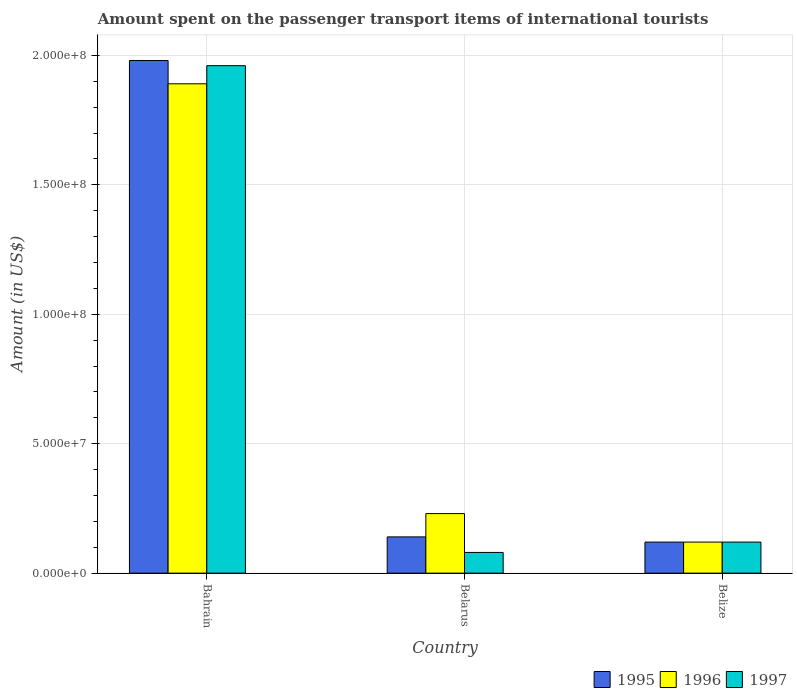How many different coloured bars are there?
Offer a very short reply. 3. How many bars are there on the 1st tick from the left?
Keep it short and to the point. 3. How many bars are there on the 1st tick from the right?
Provide a short and direct response. 3. What is the label of the 1st group of bars from the left?
Provide a short and direct response. Bahrain. In how many cases, is the number of bars for a given country not equal to the number of legend labels?
Your response must be concise. 0. What is the amount spent on the passenger transport items of international tourists in 1997 in Bahrain?
Your response must be concise. 1.96e+08. Across all countries, what is the maximum amount spent on the passenger transport items of international tourists in 1996?
Ensure brevity in your answer.  1.89e+08. Across all countries, what is the minimum amount spent on the passenger transport items of international tourists in 1996?
Your answer should be very brief. 1.20e+07. In which country was the amount spent on the passenger transport items of international tourists in 1997 maximum?
Provide a short and direct response. Bahrain. In which country was the amount spent on the passenger transport items of international tourists in 1996 minimum?
Ensure brevity in your answer.  Belize. What is the total amount spent on the passenger transport items of international tourists in 1996 in the graph?
Your answer should be very brief. 2.24e+08. What is the difference between the amount spent on the passenger transport items of international tourists in 1995 in Belarus and that in Belize?
Give a very brief answer. 2.00e+06. What is the difference between the amount spent on the passenger transport items of international tourists in 1997 in Bahrain and the amount spent on the passenger transport items of international tourists in 1996 in Belarus?
Your answer should be compact. 1.73e+08. What is the average amount spent on the passenger transport items of international tourists in 1995 per country?
Keep it short and to the point. 7.47e+07. What is the difference between the amount spent on the passenger transport items of international tourists of/in 1997 and amount spent on the passenger transport items of international tourists of/in 1995 in Belarus?
Make the answer very short. -6.00e+06. What is the ratio of the amount spent on the passenger transport items of international tourists in 1995 in Bahrain to that in Belize?
Ensure brevity in your answer.  16.5. Is the amount spent on the passenger transport items of international tourists in 1997 in Belarus less than that in Belize?
Keep it short and to the point. Yes. What is the difference between the highest and the second highest amount spent on the passenger transport items of international tourists in 1997?
Your answer should be compact. 1.84e+08. What is the difference between the highest and the lowest amount spent on the passenger transport items of international tourists in 1996?
Give a very brief answer. 1.77e+08. Is the sum of the amount spent on the passenger transport items of international tourists in 1996 in Belarus and Belize greater than the maximum amount spent on the passenger transport items of international tourists in 1995 across all countries?
Offer a terse response. No. What does the 2nd bar from the left in Bahrain represents?
Keep it short and to the point. 1996. Is it the case that in every country, the sum of the amount spent on the passenger transport items of international tourists in 1996 and amount spent on the passenger transport items of international tourists in 1995 is greater than the amount spent on the passenger transport items of international tourists in 1997?
Provide a short and direct response. Yes. Are all the bars in the graph horizontal?
Give a very brief answer. No. What is the difference between two consecutive major ticks on the Y-axis?
Provide a succinct answer. 5.00e+07. Are the values on the major ticks of Y-axis written in scientific E-notation?
Provide a short and direct response. Yes. Does the graph contain any zero values?
Offer a terse response. No. Does the graph contain grids?
Your response must be concise. Yes. How many legend labels are there?
Ensure brevity in your answer.  3. How are the legend labels stacked?
Give a very brief answer. Horizontal. What is the title of the graph?
Keep it short and to the point. Amount spent on the passenger transport items of international tourists. What is the label or title of the Y-axis?
Give a very brief answer. Amount (in US$). What is the Amount (in US$) in 1995 in Bahrain?
Make the answer very short. 1.98e+08. What is the Amount (in US$) of 1996 in Bahrain?
Provide a succinct answer. 1.89e+08. What is the Amount (in US$) of 1997 in Bahrain?
Provide a succinct answer. 1.96e+08. What is the Amount (in US$) in 1995 in Belarus?
Your response must be concise. 1.40e+07. What is the Amount (in US$) of 1996 in Belarus?
Offer a terse response. 2.30e+07. What is the Amount (in US$) in 1995 in Belize?
Your answer should be very brief. 1.20e+07. What is the Amount (in US$) in 1996 in Belize?
Ensure brevity in your answer.  1.20e+07. Across all countries, what is the maximum Amount (in US$) of 1995?
Make the answer very short. 1.98e+08. Across all countries, what is the maximum Amount (in US$) of 1996?
Your response must be concise. 1.89e+08. Across all countries, what is the maximum Amount (in US$) in 1997?
Give a very brief answer. 1.96e+08. Across all countries, what is the minimum Amount (in US$) of 1995?
Offer a terse response. 1.20e+07. Across all countries, what is the minimum Amount (in US$) of 1997?
Make the answer very short. 8.00e+06. What is the total Amount (in US$) of 1995 in the graph?
Your answer should be compact. 2.24e+08. What is the total Amount (in US$) in 1996 in the graph?
Provide a short and direct response. 2.24e+08. What is the total Amount (in US$) in 1997 in the graph?
Provide a succinct answer. 2.16e+08. What is the difference between the Amount (in US$) in 1995 in Bahrain and that in Belarus?
Offer a terse response. 1.84e+08. What is the difference between the Amount (in US$) in 1996 in Bahrain and that in Belarus?
Provide a short and direct response. 1.66e+08. What is the difference between the Amount (in US$) of 1997 in Bahrain and that in Belarus?
Keep it short and to the point. 1.88e+08. What is the difference between the Amount (in US$) of 1995 in Bahrain and that in Belize?
Your answer should be very brief. 1.86e+08. What is the difference between the Amount (in US$) in 1996 in Bahrain and that in Belize?
Make the answer very short. 1.77e+08. What is the difference between the Amount (in US$) in 1997 in Bahrain and that in Belize?
Your response must be concise. 1.84e+08. What is the difference between the Amount (in US$) in 1996 in Belarus and that in Belize?
Offer a very short reply. 1.10e+07. What is the difference between the Amount (in US$) in 1995 in Bahrain and the Amount (in US$) in 1996 in Belarus?
Provide a succinct answer. 1.75e+08. What is the difference between the Amount (in US$) in 1995 in Bahrain and the Amount (in US$) in 1997 in Belarus?
Keep it short and to the point. 1.90e+08. What is the difference between the Amount (in US$) in 1996 in Bahrain and the Amount (in US$) in 1997 in Belarus?
Your answer should be very brief. 1.81e+08. What is the difference between the Amount (in US$) in 1995 in Bahrain and the Amount (in US$) in 1996 in Belize?
Make the answer very short. 1.86e+08. What is the difference between the Amount (in US$) of 1995 in Bahrain and the Amount (in US$) of 1997 in Belize?
Offer a very short reply. 1.86e+08. What is the difference between the Amount (in US$) in 1996 in Bahrain and the Amount (in US$) in 1997 in Belize?
Your response must be concise. 1.77e+08. What is the difference between the Amount (in US$) of 1995 in Belarus and the Amount (in US$) of 1996 in Belize?
Provide a succinct answer. 2.00e+06. What is the difference between the Amount (in US$) of 1995 in Belarus and the Amount (in US$) of 1997 in Belize?
Make the answer very short. 2.00e+06. What is the difference between the Amount (in US$) of 1996 in Belarus and the Amount (in US$) of 1997 in Belize?
Provide a short and direct response. 1.10e+07. What is the average Amount (in US$) of 1995 per country?
Give a very brief answer. 7.47e+07. What is the average Amount (in US$) in 1996 per country?
Ensure brevity in your answer.  7.47e+07. What is the average Amount (in US$) in 1997 per country?
Give a very brief answer. 7.20e+07. What is the difference between the Amount (in US$) in 1995 and Amount (in US$) in 1996 in Bahrain?
Your answer should be very brief. 9.00e+06. What is the difference between the Amount (in US$) of 1995 and Amount (in US$) of 1997 in Bahrain?
Keep it short and to the point. 2.00e+06. What is the difference between the Amount (in US$) in 1996 and Amount (in US$) in 1997 in Bahrain?
Your answer should be compact. -7.00e+06. What is the difference between the Amount (in US$) of 1995 and Amount (in US$) of 1996 in Belarus?
Keep it short and to the point. -9.00e+06. What is the difference between the Amount (in US$) in 1995 and Amount (in US$) in 1997 in Belarus?
Provide a short and direct response. 6.00e+06. What is the difference between the Amount (in US$) of 1996 and Amount (in US$) of 1997 in Belarus?
Make the answer very short. 1.50e+07. What is the difference between the Amount (in US$) of 1995 and Amount (in US$) of 1996 in Belize?
Ensure brevity in your answer.  0. What is the difference between the Amount (in US$) of 1995 and Amount (in US$) of 1997 in Belize?
Ensure brevity in your answer.  0. What is the ratio of the Amount (in US$) in 1995 in Bahrain to that in Belarus?
Offer a very short reply. 14.14. What is the ratio of the Amount (in US$) in 1996 in Bahrain to that in Belarus?
Ensure brevity in your answer.  8.22. What is the ratio of the Amount (in US$) of 1995 in Bahrain to that in Belize?
Your answer should be very brief. 16.5. What is the ratio of the Amount (in US$) of 1996 in Bahrain to that in Belize?
Provide a short and direct response. 15.75. What is the ratio of the Amount (in US$) in 1997 in Bahrain to that in Belize?
Offer a terse response. 16.33. What is the ratio of the Amount (in US$) of 1996 in Belarus to that in Belize?
Your answer should be very brief. 1.92. What is the difference between the highest and the second highest Amount (in US$) in 1995?
Your answer should be very brief. 1.84e+08. What is the difference between the highest and the second highest Amount (in US$) of 1996?
Ensure brevity in your answer.  1.66e+08. What is the difference between the highest and the second highest Amount (in US$) of 1997?
Your answer should be compact. 1.84e+08. What is the difference between the highest and the lowest Amount (in US$) of 1995?
Your response must be concise. 1.86e+08. What is the difference between the highest and the lowest Amount (in US$) in 1996?
Keep it short and to the point. 1.77e+08. What is the difference between the highest and the lowest Amount (in US$) in 1997?
Provide a short and direct response. 1.88e+08. 